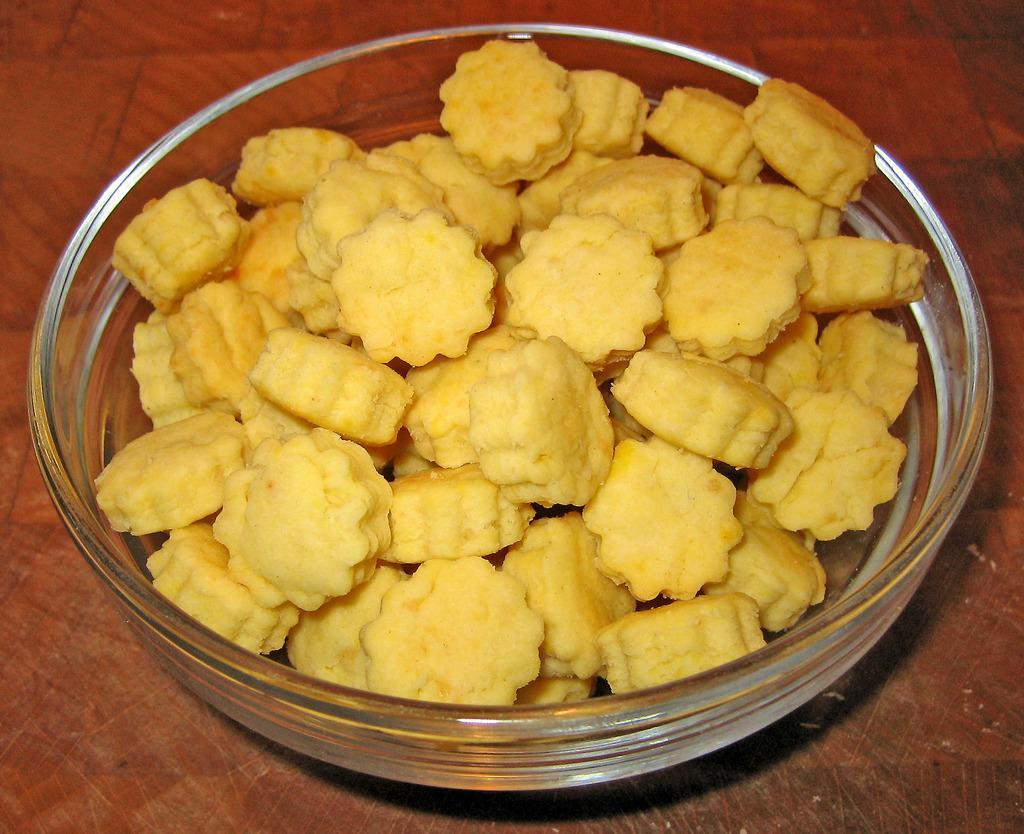How would you summarize this image in a sentence or two? In this image we can see some food item in a bowl, which is on the wooden surface. 